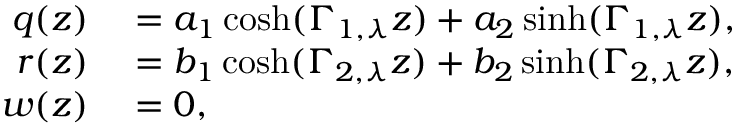Convert formula to latex. <formula><loc_0><loc_0><loc_500><loc_500>\begin{array} { r l } { q ( z ) } & = a _ { 1 } \cosh ( \Gamma _ { 1 , \lambda } z ) + a _ { 2 } \sinh ( \Gamma _ { 1 , \lambda } z ) , } \\ { r ( z ) } & = b _ { 1 } \cosh ( \Gamma _ { 2 , \lambda } z ) + b _ { 2 } \sinh ( \Gamma _ { 2 , \lambda } z ) , } \\ { w ( z ) } & = 0 , } \end{array}</formula> 